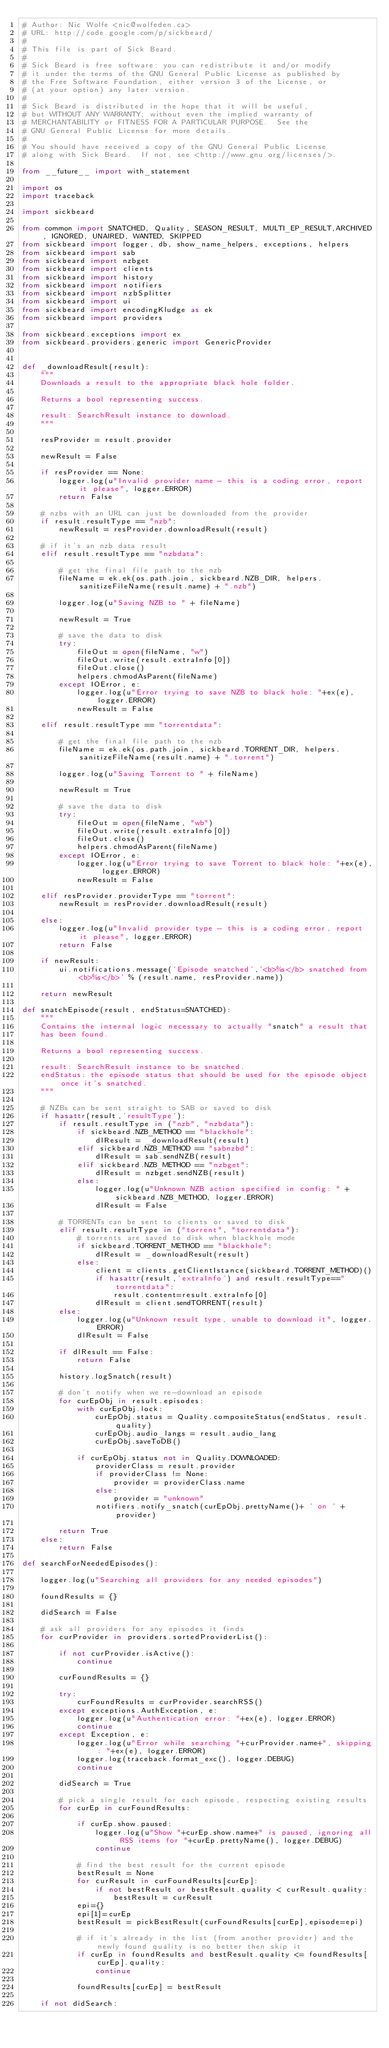Convert code to text. <code><loc_0><loc_0><loc_500><loc_500><_Python_># Author: Nic Wolfe <nic@wolfeden.ca>
# URL: http://code.google.com/p/sickbeard/
#
# This file is part of Sick Beard.
#
# Sick Beard is free software: you can redistribute it and/or modify
# it under the terms of the GNU General Public License as published by
# the Free Software Foundation, either version 3 of the License, or
# (at your option) any later version.
#
# Sick Beard is distributed in the hope that it will be useful,
# but WITHOUT ANY WARRANTY; without even the implied warranty of
# MERCHANTABILITY or FITNESS FOR A PARTICULAR PURPOSE.  See the
# GNU General Public License for more details.
#
# You should have received a copy of the GNU General Public License
# along with Sick Beard.  If not, see <http://www.gnu.org/licenses/>.

from __future__ import with_statement

import os
import traceback

import sickbeard

from common import SNATCHED, Quality, SEASON_RESULT, MULTI_EP_RESULT,ARCHIVED, IGNORED, UNAIRED, WANTED, SKIPPED
from sickbeard import logger, db, show_name_helpers, exceptions, helpers
from sickbeard import sab
from sickbeard import nzbget
from sickbeard import clients
from sickbeard import history
from sickbeard import notifiers
from sickbeard import nzbSplitter
from sickbeard import ui
from sickbeard import encodingKludge as ek
from sickbeard import providers

from sickbeard.exceptions import ex
from sickbeard.providers.generic import GenericProvider


def _downloadResult(result):
    """
    Downloads a result to the appropriate black hole folder.
    
    Returns a bool representing success.
    
    result: SearchResult instance to download.
    """

    resProvider = result.provider

    newResult = False

    if resProvider == None:
        logger.log(u"Invalid provider name - this is a coding error, report it please", logger.ERROR)
        return False

    # nzbs with an URL can just be downloaded from the provider
    if result.resultType == "nzb":
        newResult = resProvider.downloadResult(result)

    # if it's an nzb data result 
    elif result.resultType == "nzbdata":
        
        # get the final file path to the nzb
        fileName = ek.ek(os.path.join, sickbeard.NZB_DIR, helpers.sanitizeFileName(result.name) + ".nzb")

        logger.log(u"Saving NZB to " + fileName)

        newResult = True

        # save the data to disk
        try:
            fileOut = open(fileName, "w")
            fileOut.write(result.extraInfo[0])
            fileOut.close()
            helpers.chmodAsParent(fileName)
        except IOError, e:
            logger.log(u"Error trying to save NZB to black hole: "+ex(e), logger.ERROR)
            newResult = False

    elif result.resultType == "torrentdata":
        
        # get the final file path to the nzb
        fileName = ek.ek(os.path.join, sickbeard.TORRENT_DIR, helpers.sanitizeFileName(result.name) + ".torrent")

        logger.log(u"Saving Torrent to " + fileName)

        newResult = True

        # save the data to disk
        try:
            fileOut = open(fileName, "wb")
            fileOut.write(result.extraInfo[0])
            fileOut.close()
            helpers.chmodAsParent(fileName)
        except IOError, e:
            logger.log(u"Error trying to save Torrent to black hole: "+ex(e), logger.ERROR)
            newResult = False

    elif resProvider.providerType == "torrent":
        newResult = resProvider.downloadResult(result)

    else:
        logger.log(u"Invalid provider type - this is a coding error, report it please", logger.ERROR)
        return False

    if newResult:
        ui.notifications.message('Episode snatched','<b>%s</b> snatched from <b>%s</b>' % (result.name, resProvider.name))

    return newResult

def snatchEpisode(result, endStatus=SNATCHED):
    """
    Contains the internal logic necessary to actually "snatch" a result that
    has been found.
    
    Returns a bool representing success.
    
    result: SearchResult instance to be snatched.
    endStatus: the episode status that should be used for the episode object once it's snatched.
    """

    # NZBs can be sent straight to SAB or saved to disk
    if hasattr(result,'resultType'):
        if result.resultType in ("nzb", "nzbdata"):
            if sickbeard.NZB_METHOD == "blackhole":
                dlResult = _downloadResult(result)
            elif sickbeard.NZB_METHOD == "sabnzbd":
                dlResult = sab.sendNZB(result)
            elif sickbeard.NZB_METHOD == "nzbget":
                dlResult = nzbget.sendNZB(result)
            else:
                logger.log(u"Unknown NZB action specified in config: " + sickbeard.NZB_METHOD, logger.ERROR)
                dlResult = False
    
        # TORRENTs can be sent to clients or saved to disk
        elif result.resultType in ("torrent", "torrentdata"):
            # torrents are saved to disk when blackhole mode
            if sickbeard.TORRENT_METHOD == "blackhole": 
                dlResult = _downloadResult(result)
            else:
                client = clients.getClientIstance(sickbeard.TORRENT_METHOD)()
                if hasattr(result,'extraInfo') and result.resultType=="torrentdata":
                    result.content=result.extraInfo[0]
                dlResult = client.sendTORRENT(result)
        else:
            logger.log(u"Unknown result type, unable to download it", logger.ERROR)
            dlResult = False
    
        if dlResult == False:
            return False
    
        history.logSnatch(result)
    
        # don't notify when we re-download an episode
        for curEpObj in result.episodes:
            with curEpObj.lock:
                curEpObj.status = Quality.compositeStatus(endStatus, result.quality)
                curEpObj.audio_langs = result.audio_lang
                curEpObj.saveToDB()
    
            if curEpObj.status not in Quality.DOWNLOADED:
                providerClass = result.provider
                if providerClass != None:
                    provider = providerClass.name
                else:
                    provider = "unknown"
                notifiers.notify_snatch(curEpObj.prettyName()+ ' on ' + provider)
    
        return True
    else:
        return False

def searchForNeededEpisodes():

    logger.log(u"Searching all providers for any needed episodes")

    foundResults = {}

    didSearch = False

    # ask all providers for any episodes it finds
    for curProvider in providers.sortedProviderList():

        if not curProvider.isActive():
            continue

        curFoundResults = {}

        try:
            curFoundResults = curProvider.searchRSS()
        except exceptions.AuthException, e:
            logger.log(u"Authentication error: "+ex(e), logger.ERROR)
            continue
        except Exception, e:
            logger.log(u"Error while searching "+curProvider.name+", skipping: "+ex(e), logger.ERROR)
            logger.log(traceback.format_exc(), logger.DEBUG)
            continue

        didSearch = True

        # pick a single result for each episode, respecting existing results
        for curEp in curFoundResults:

            if curEp.show.paused:
                logger.log(u"Show "+curEp.show.name+" is paused, ignoring all RSS items for "+curEp.prettyName(), logger.DEBUG)
                continue

            # find the best result for the current episode
            bestResult = None
            for curResult in curFoundResults[curEp]:
                if not bestResult or bestResult.quality < curResult.quality:
                    bestResult = curResult
            epi={}
            epi[1]=curEp
            bestResult = pickBestResult(curFoundResults[curEp],episode=epi)

            # if it's already in the list (from another provider) and the newly found quality is no better then skip it
            if curEp in foundResults and bestResult.quality <= foundResults[curEp].quality:
                continue

            foundResults[curEp] = bestResult

    if not didSearch:</code> 